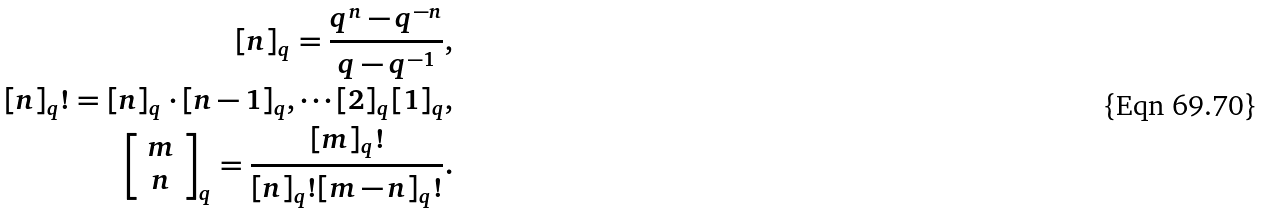<formula> <loc_0><loc_0><loc_500><loc_500>[ n ] _ { q } = \frac { q ^ { n } - q ^ { - n } } { q - q ^ { - 1 } } , \\ [ n ] _ { q } ! = [ n ] _ { q } \cdot [ n - 1 ] _ { q } , \cdots [ 2 ] _ { q } [ 1 ] _ { q } , \\ \left [ \begin{array} { c } m \\ n \end{array} \right ] _ { q } = \frac { [ m ] _ { q } ! } { [ n ] _ { q } ! [ m - n ] _ { q } ! } .</formula> 